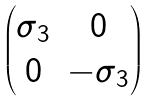Convert formula to latex. <formula><loc_0><loc_0><loc_500><loc_500>\begin{pmatrix} \sigma _ { 3 } & 0 \\ 0 & - \sigma _ { 3 } \end{pmatrix}</formula> 